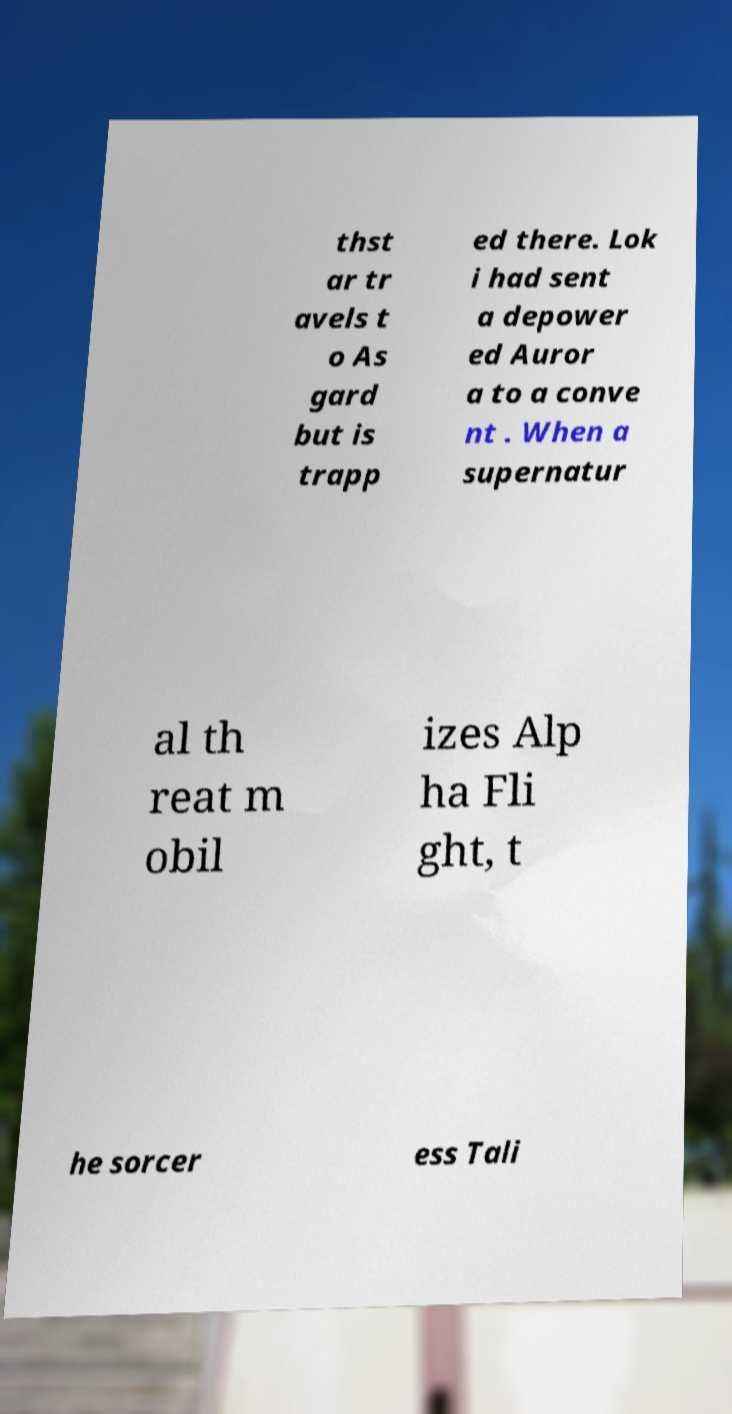I need the written content from this picture converted into text. Can you do that? thst ar tr avels t o As gard but is trapp ed there. Lok i had sent a depower ed Auror a to a conve nt . When a supernatur al th reat m obil izes Alp ha Fli ght, t he sorcer ess Tali 